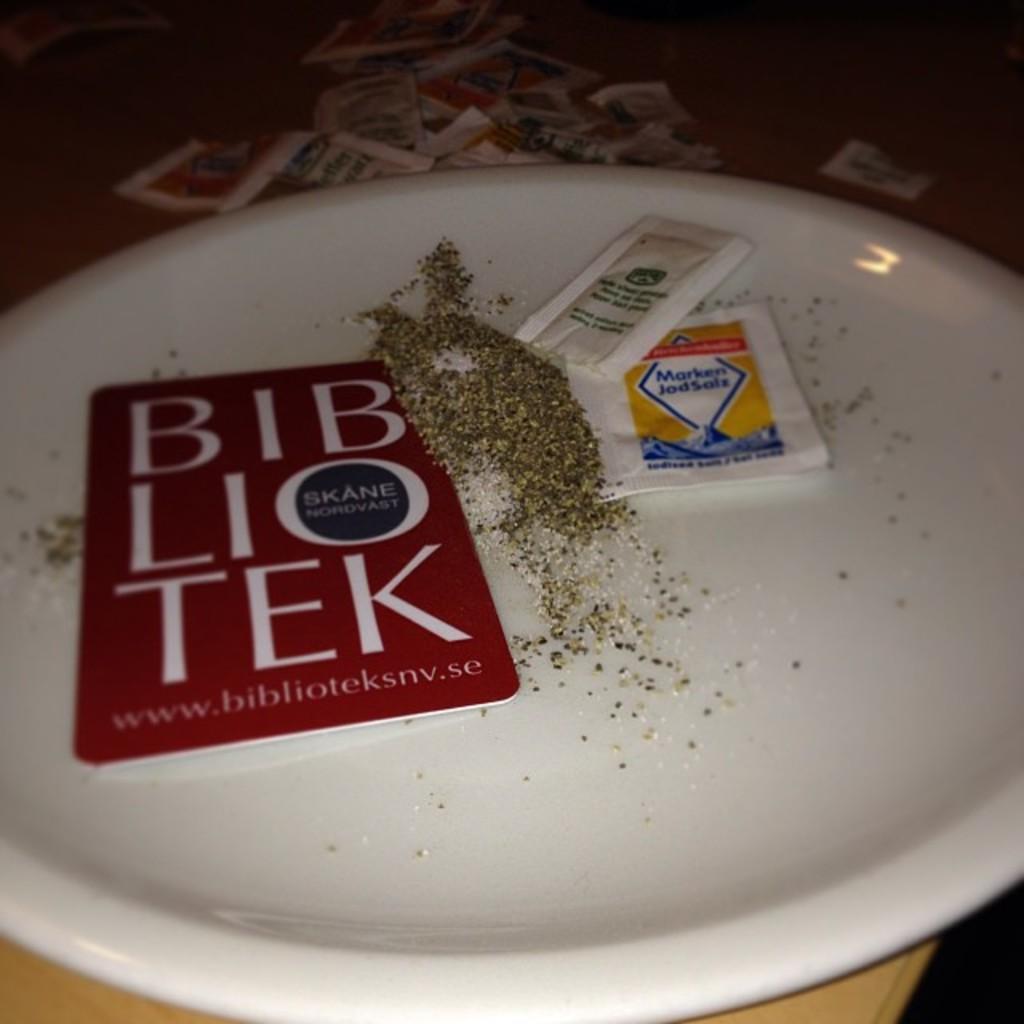Can you describe this image briefly? In this image there is a plate on a table. On the plate there are food packets and a paper with text. There are also herbs and salt on the plate. At the top there are food packets on the table. 